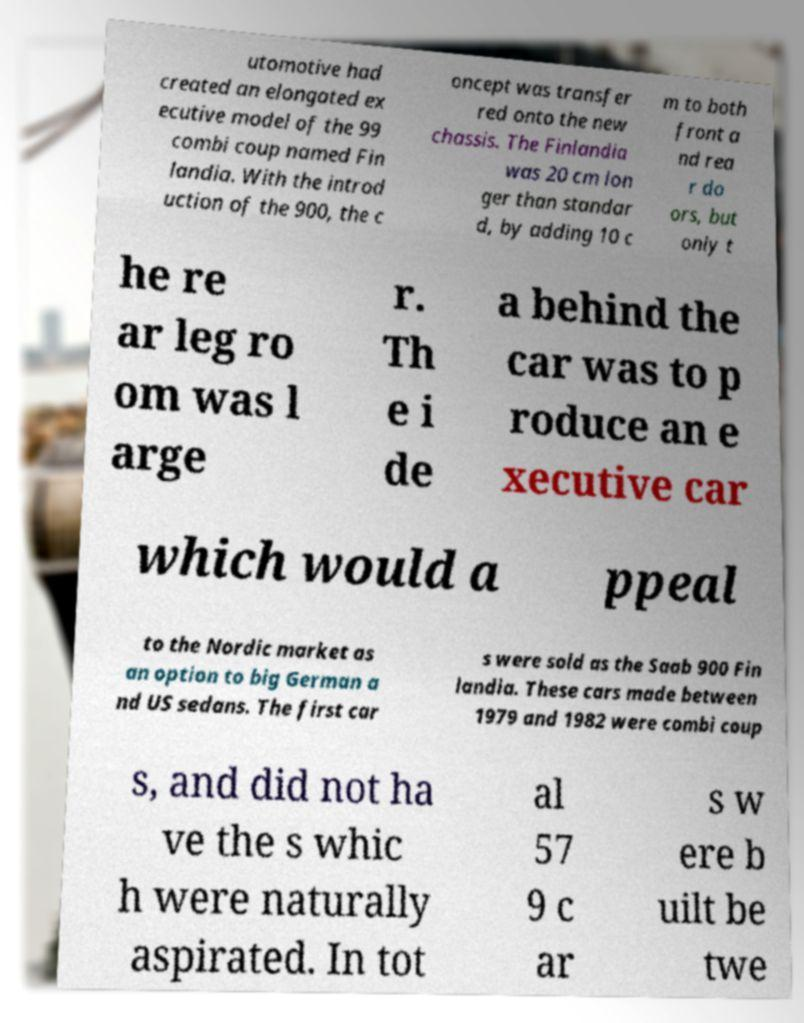Could you extract and type out the text from this image? utomotive had created an elongated ex ecutive model of the 99 combi coup named Fin landia. With the introd uction of the 900, the c oncept was transfer red onto the new chassis. The Finlandia was 20 cm lon ger than standar d, by adding 10 c m to both front a nd rea r do ors, but only t he re ar leg ro om was l arge r. Th e i de a behind the car was to p roduce an e xecutive car which would a ppeal to the Nordic market as an option to big German a nd US sedans. The first car s were sold as the Saab 900 Fin landia. These cars made between 1979 and 1982 were combi coup s, and did not ha ve the s whic h were naturally aspirated. In tot al 57 9 c ar s w ere b uilt be twe 